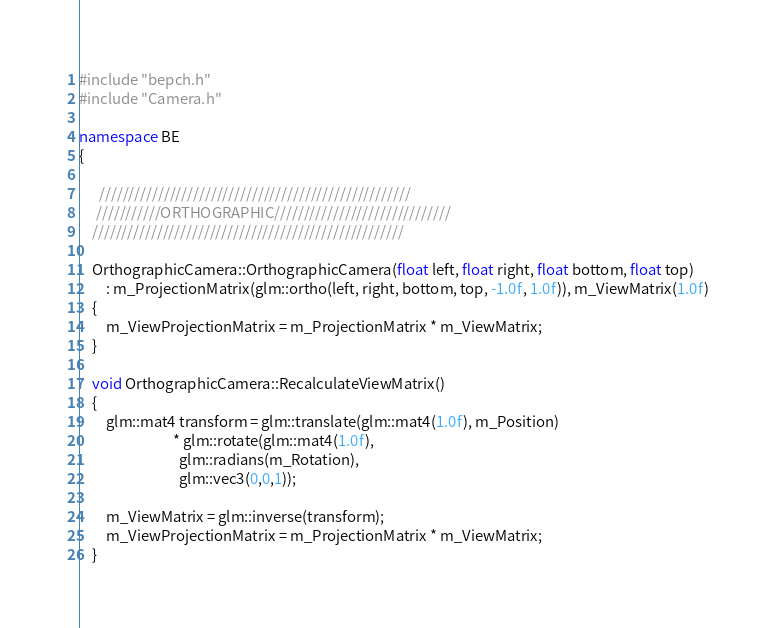<code> <loc_0><loc_0><loc_500><loc_500><_C++_>#include "bepch.h"
#include "Camera.h"

namespace BE
{

	  /////////////////////////////////////////////////////
	 ///////////ORTHOGRAPHIC//////////////////////////////
	/////////////////////////////////////////////////////

	OrthographicCamera::OrthographicCamera(float left, float right, float bottom, float top)
		: m_ProjectionMatrix(glm::ortho(left, right, bottom, top, -1.0f, 1.0f)), m_ViewMatrix(1.0f)
	{
		m_ViewProjectionMatrix = m_ProjectionMatrix * m_ViewMatrix; 
	}

	void OrthographicCamera::RecalculateViewMatrix() 
	{
		glm::mat4 transform = glm::translate(glm::mat4(1.0f), m_Position)
							* glm::rotate(glm::mat4(1.0f),
							  glm::radians(m_Rotation),
							  glm::vec3(0,0,1));

		m_ViewMatrix = glm::inverse(transform);
		m_ViewProjectionMatrix = m_ProjectionMatrix * m_ViewMatrix;
	}

</code> 